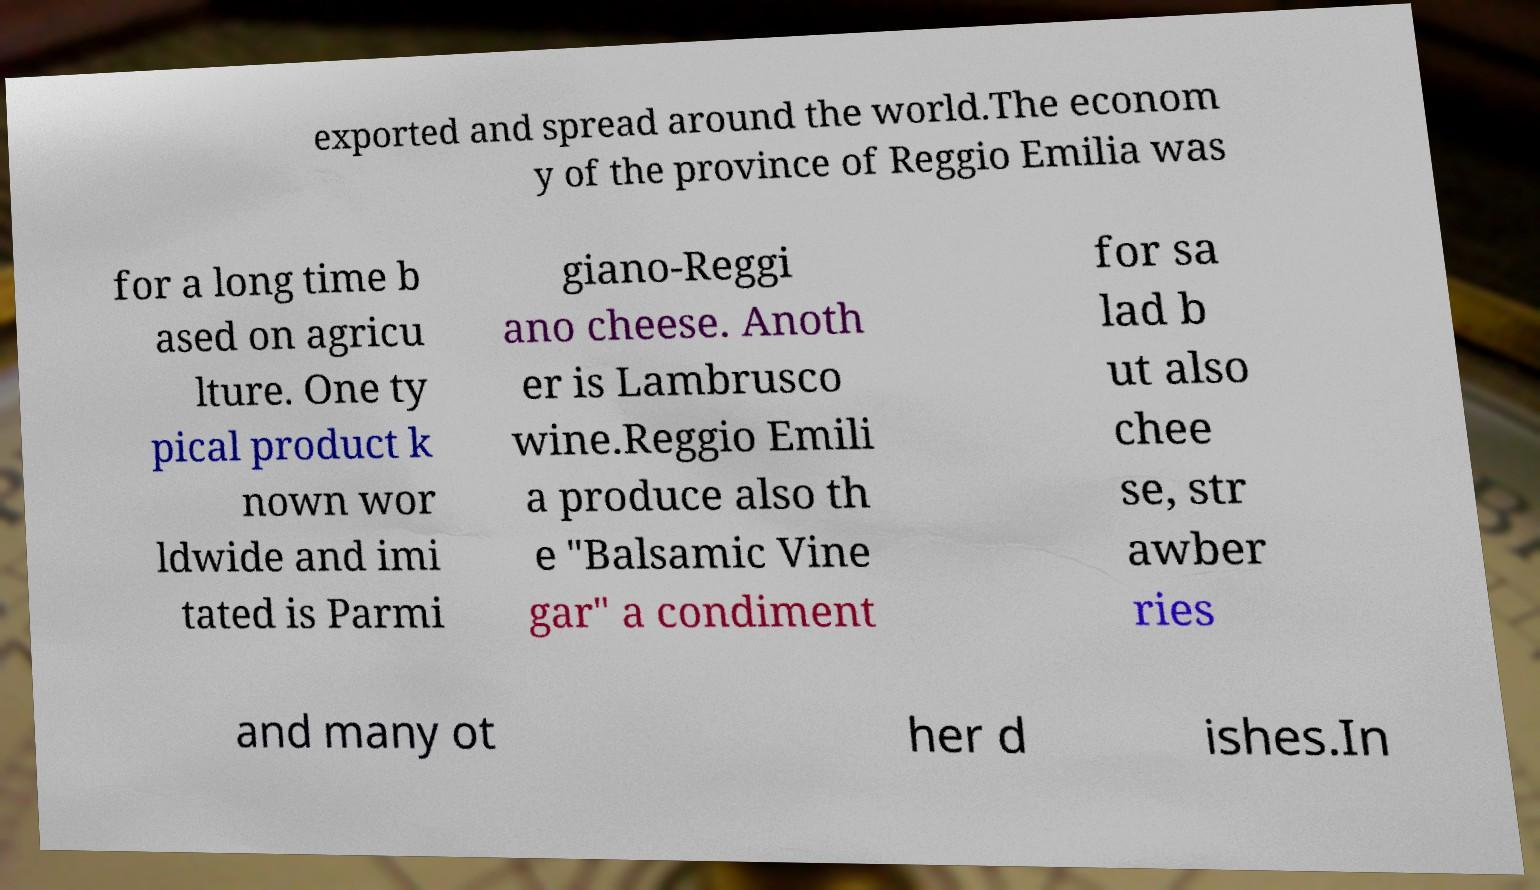I need the written content from this picture converted into text. Can you do that? exported and spread around the world.The econom y of the province of Reggio Emilia was for a long time b ased on agricu lture. One ty pical product k nown wor ldwide and imi tated is Parmi giano-Reggi ano cheese. Anoth er is Lambrusco wine.Reggio Emili a produce also th e "Balsamic Vine gar" a condiment for sa lad b ut also chee se, str awber ries and many ot her d ishes.In 